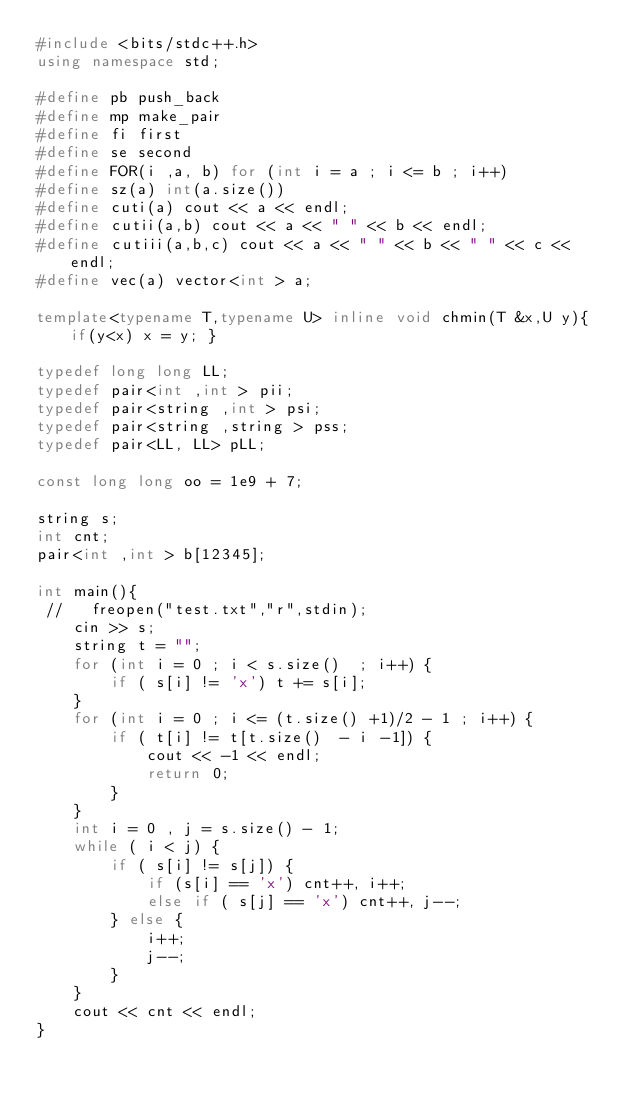<code> <loc_0><loc_0><loc_500><loc_500><_C++_>#include <bits/stdc++.h>
using namespace std;

#define pb push_back
#define mp make_pair
#define fi first
#define se second
#define FOR(i ,a, b) for (int i = a ; i <= b ; i++)
#define sz(a) int(a.size())
#define cuti(a) cout << a << endl;
#define cutii(a,b) cout << a << " " << b << endl;
#define cutiii(a,b,c) cout << a << " " << b << " " << c << endl;
#define vec(a) vector<int > a;

template<typename T,typename U> inline void chmin(T &x,U y){ if(y<x) x = y; }

typedef long long LL;
typedef pair<int ,int > pii;
typedef pair<string ,int > psi;
typedef pair<string ,string > pss;
typedef pair<LL, LL> pLL;

const long long oo = 1e9 + 7;

string s;
int cnt;
pair<int ,int > b[12345];

int main(){
 //   freopen("test.txt","r",stdin);
    cin >> s;
    string t = "";
    for (int i = 0 ; i < s.size()  ; i++) {
        if ( s[i] != 'x') t += s[i];
    }
    for (int i = 0 ; i <= (t.size() +1)/2 - 1 ; i++) {
        if ( t[i] != t[t.size()  - i -1]) {
            cout << -1 << endl;
            return 0;
        }
    }
    int i = 0 , j = s.size() - 1;
    while ( i < j) {
        if ( s[i] != s[j]) {
            if (s[i] == 'x') cnt++, i++;
            else if ( s[j] == 'x') cnt++, j--;
        } else {
            i++;
            j--;
        }
    }
    cout << cnt << endl;
}
</code> 